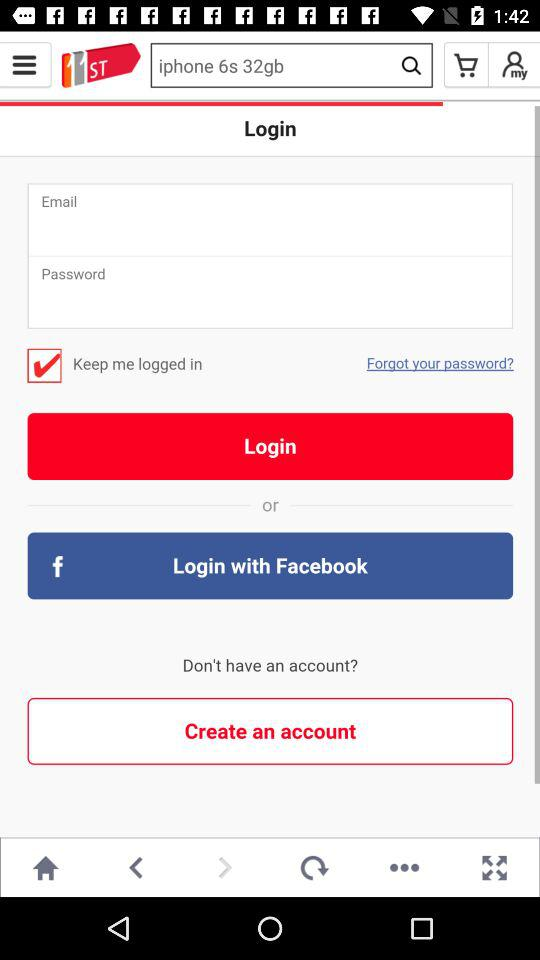What's the offer validity period to join and win an iPhone 7? The offer is valid from December 1, 2016 to December 31, 2016. 